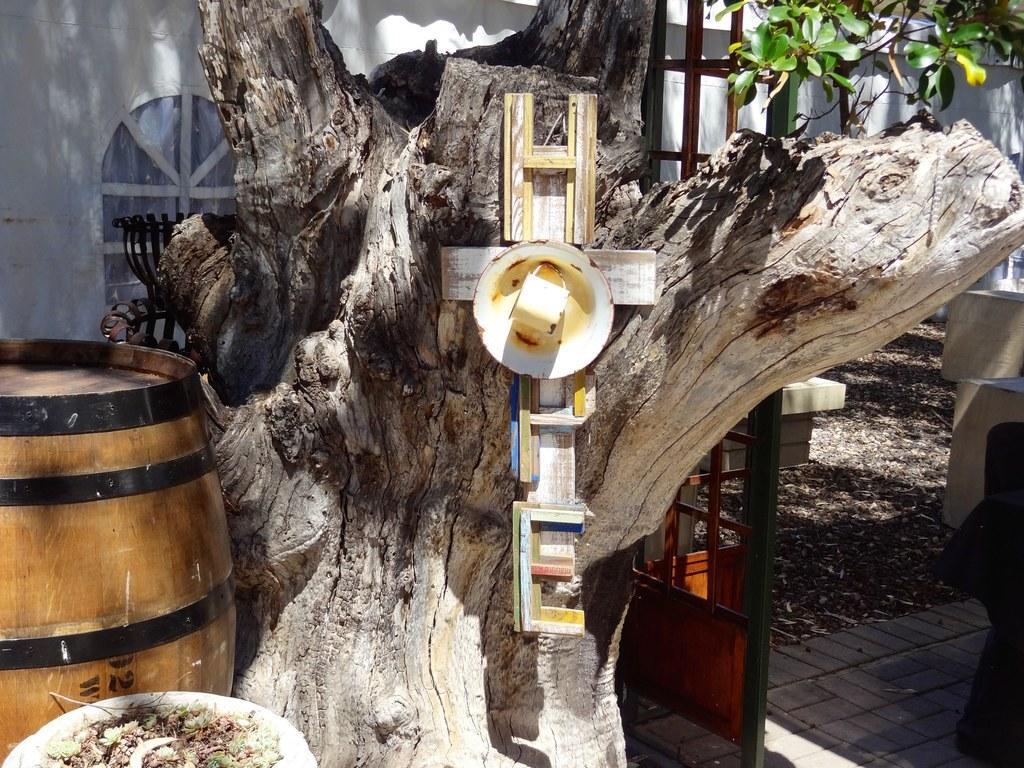In one or two sentences, can you explain what this image depicts? In this image there is a barrel. Beside the barrel there are wooden letters on the trunk of a tree. In the background of the image there is a metal rod fence, concrete structures. There is a window on the wall and there is a tree. In front of the barrel there is a trunk. 